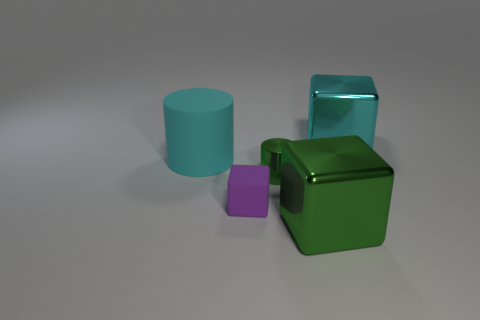Do the purple cube and the shiny cube that is behind the large green thing have the same size?
Provide a succinct answer. No. The cyan shiny block has what size?
Your answer should be very brief. Large. There is a tiny cylinder that is made of the same material as the big green thing; what is its color?
Provide a short and direct response. Green. What number of cyan blocks have the same material as the large green object?
Your response must be concise. 1. What number of things are either cyan metal spheres or big objects behind the large green shiny block?
Keep it short and to the point. 2. Is the material of the large green block in front of the purple rubber object the same as the purple block?
Keep it short and to the point. No. There is a cylinder that is the same size as the cyan cube; what color is it?
Your answer should be compact. Cyan. Are there any other green things that have the same shape as the small green metallic thing?
Your answer should be very brief. No. There is a large shiny block in front of the big cube that is behind the large shiny cube left of the cyan metallic cube; what color is it?
Ensure brevity in your answer.  Green. How many metallic things are either big cubes or cyan blocks?
Give a very brief answer. 2. 